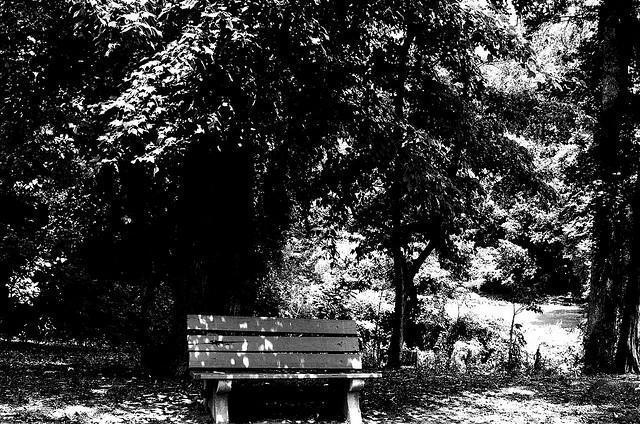How many benches are there?
Give a very brief answer. 1. How many people are wearing black shirt?
Give a very brief answer. 0. 